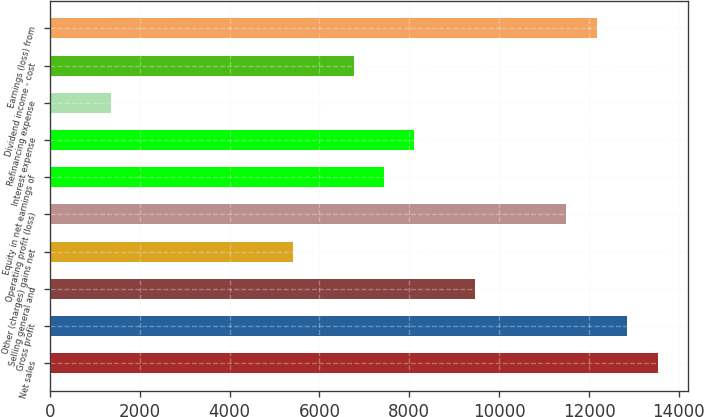Convert chart to OTSL. <chart><loc_0><loc_0><loc_500><loc_500><bar_chart><fcel>Net sales<fcel>Gross profit<fcel>Selling general and<fcel>Other (charges) gains net<fcel>Operating profit (loss)<fcel>Equity in net earnings of<fcel>Interest expense<fcel>Refinancing expense<fcel>Dividend income - cost<fcel>Earnings (loss) from<nl><fcel>13525<fcel>12848.8<fcel>9467.8<fcel>5410.6<fcel>11496.4<fcel>7439.2<fcel>8115.4<fcel>1353.4<fcel>6763<fcel>12172.6<nl></chart> 